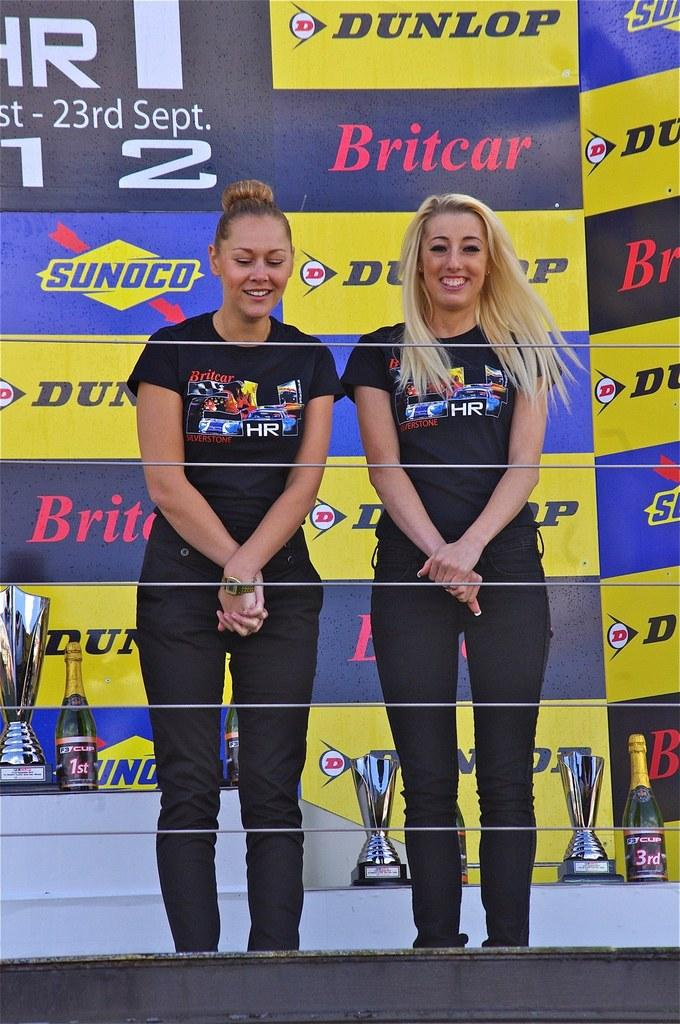<image>
Create a compact narrative representing the image presented. Two people standing in front of a large wall that says "Sunoco" on it. 